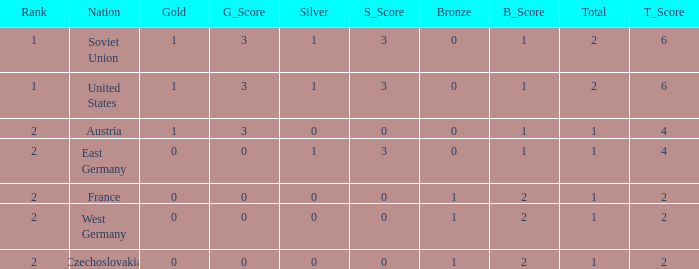What is the highest rank of Austria, which had less than 0 silvers? None. 